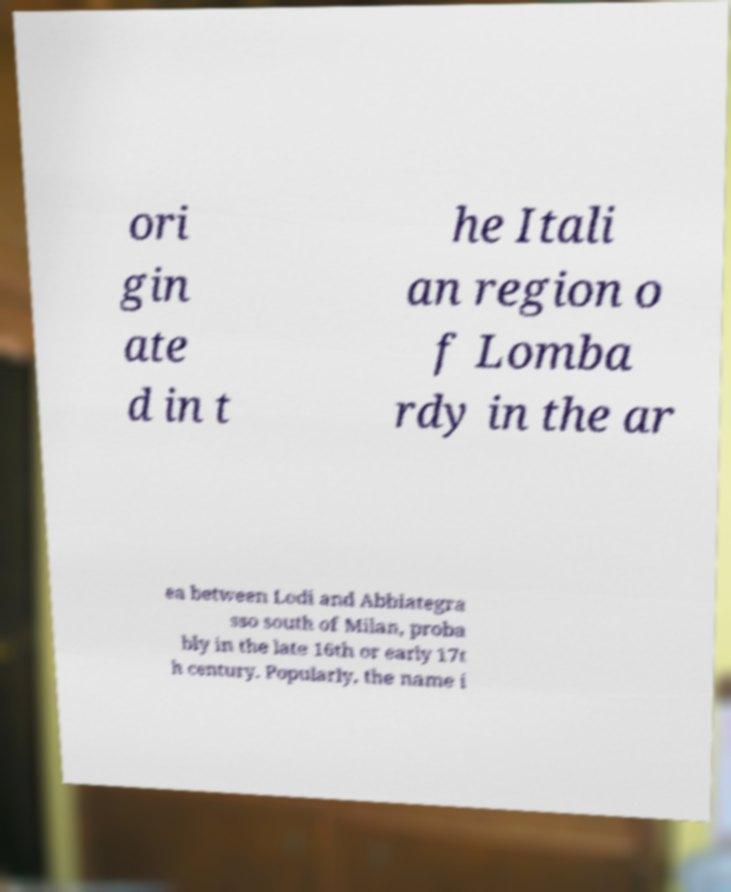What messages or text are displayed in this image? I need them in a readable, typed format. ori gin ate d in t he Itali an region o f Lomba rdy in the ar ea between Lodi and Abbiategra sso south of Milan, proba bly in the late 16th or early 17t h century. Popularly, the name i 